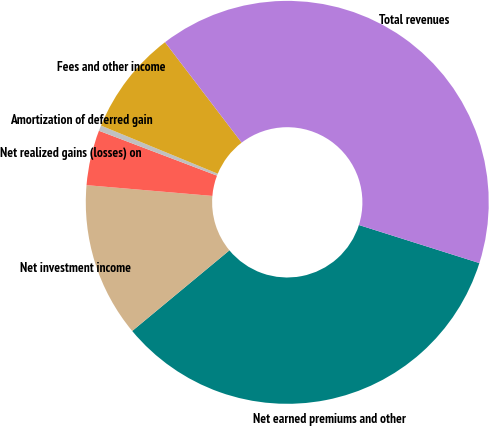Convert chart. <chart><loc_0><loc_0><loc_500><loc_500><pie_chart><fcel>Net earned premiums and other<fcel>Net investment income<fcel>Net realized gains (losses) on<fcel>Amortization of deferred gain<fcel>Fees and other income<fcel>Total revenues<nl><fcel>34.1%<fcel>12.38%<fcel>4.42%<fcel>0.44%<fcel>8.4%<fcel>40.24%<nl></chart> 